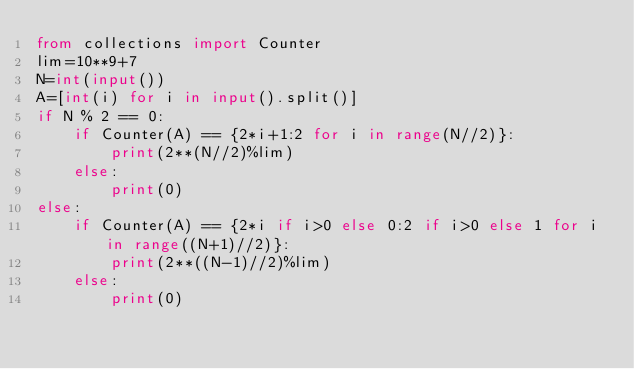<code> <loc_0><loc_0><loc_500><loc_500><_Python_>from collections import Counter
lim=10**9+7
N=int(input())
A=[int(i) for i in input().split()]
if N % 2 == 0:
    if Counter(A) == {2*i+1:2 for i in range(N//2)}:
        print(2**(N//2)%lim)
    else:
        print(0)
else:
    if Counter(A) == {2*i if i>0 else 0:2 if i>0 else 1 for i in range((N+1)//2)}:
        print(2**((N-1)//2)%lim)
    else:
        print(0)</code> 